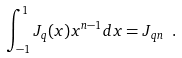Convert formula to latex. <formula><loc_0><loc_0><loc_500><loc_500>\int ^ { 1 } _ { - 1 } J _ { q } ( x ) x ^ { n - 1 } d x = J _ { q n } \ .</formula> 